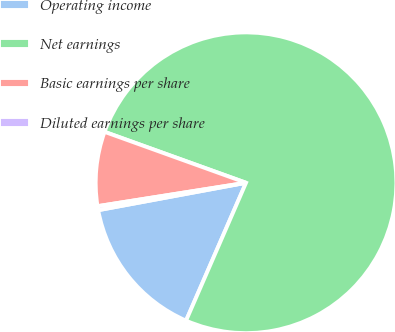Convert chart to OTSL. <chart><loc_0><loc_0><loc_500><loc_500><pie_chart><fcel>Operating income<fcel>Net earnings<fcel>Basic earnings per share<fcel>Diluted earnings per share<nl><fcel>15.55%<fcel>76.03%<fcel>7.99%<fcel>0.43%<nl></chart> 